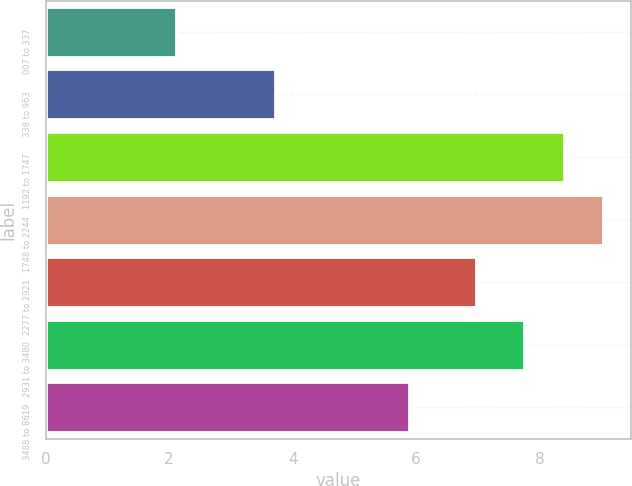<chart> <loc_0><loc_0><loc_500><loc_500><bar_chart><fcel>007 to 337<fcel>338 to 963<fcel>1192 to 1747<fcel>1748 to 2244<fcel>2277 to 2921<fcel>2931 to 3480<fcel>3488 to 8619<nl><fcel>2.11<fcel>3.71<fcel>8.39<fcel>9.03<fcel>6.97<fcel>7.75<fcel>5.88<nl></chart> 